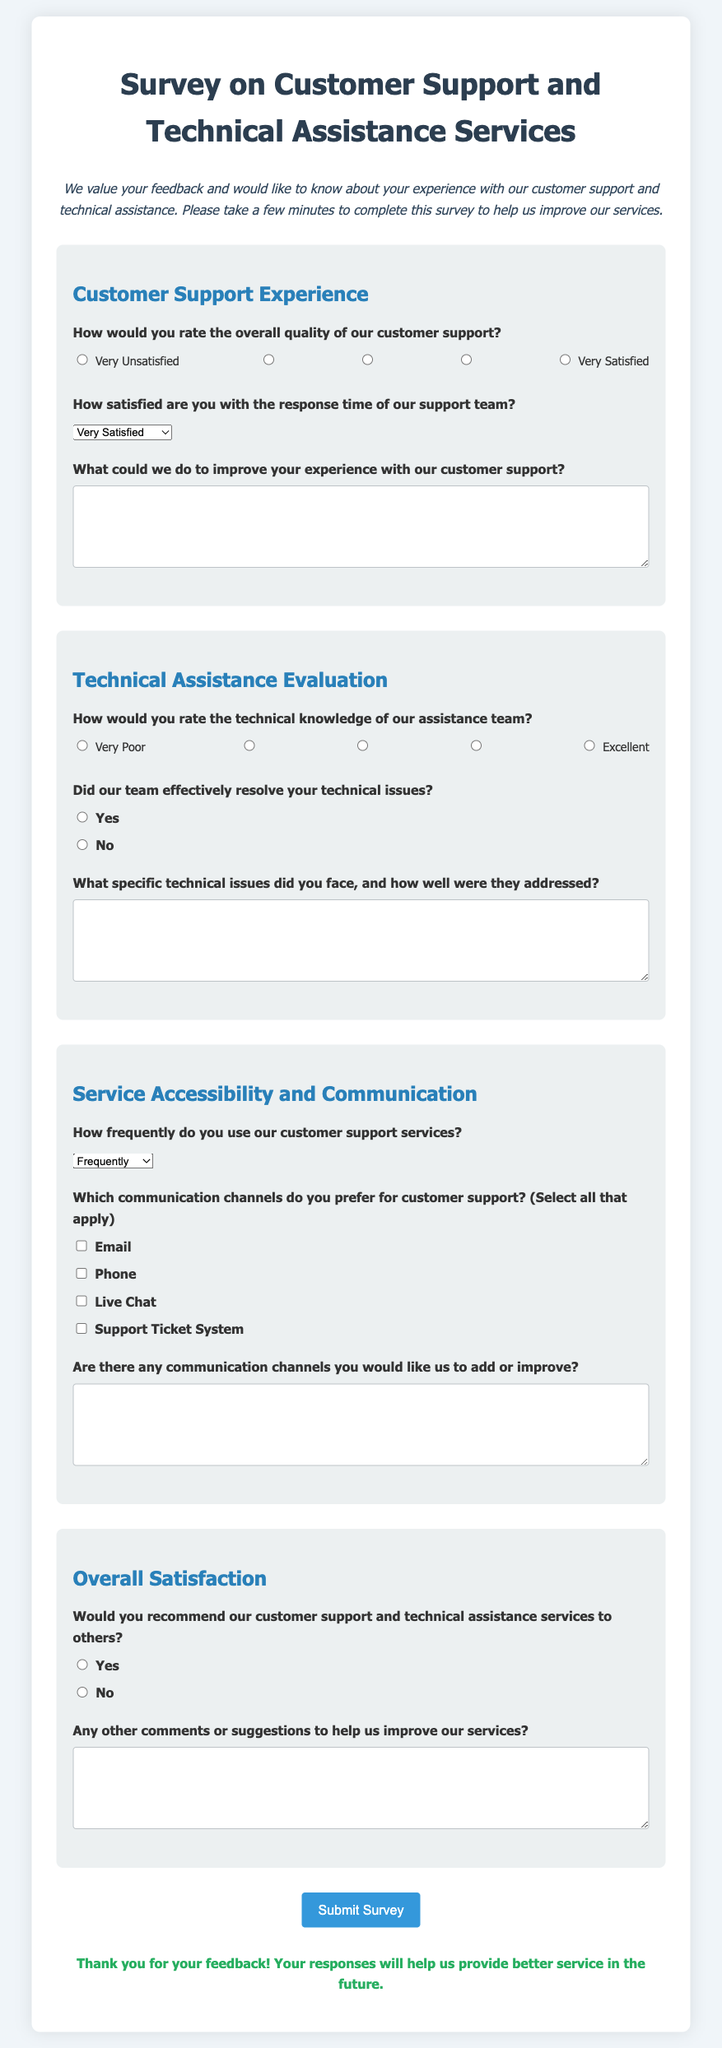What is the title of the survey? The title of the survey is displayed prominently at the top of the document.
Answer: Survey on Customer Support and Technical Assistance Services How many sections are there in the survey? The document outlines different sections of the survey, which are labeled in the HTML structure.
Answer: Four What is the first question in the Customer Support Experience section? The first question is stated under the Customer Support Experience section heading.
Answer: How would you rate the overall quality of our customer support? What scale is used to rate the overall quality of customer support? The rating scale consists of options ranging from very unsatisfied to very satisfied.
Answer: 1 to 5 What communication channel is NOT listed in the section on service accessibility? The document lists several channels but does not include an option.
Answer: None How would you rate the technical knowledge of our assistance team? This question asks about the technical knowledge level and is followed by a rating scale from very poor to excellent.
Answer: 1 to 5 What type of feedback is requested in the comment section? The document asks for general comments or suggestions regarding the services.
Answer: Any other comments or suggestions to help us improve our services? Is there a thank you message after the survey submission? The presence of a thank you message is indicated in the final part of the document.
Answer: Yes Which option is used to indicate satisfaction with the response time of the support team? The satisfaction with response time is gauged through a selection of terms provided in the survey.
Answer: Very Satisfied to Very Dissatisfied What action does the button at the end of the survey prompt? The button is intended for submitting responses to the survey questions.
Answer: Submit Survey 